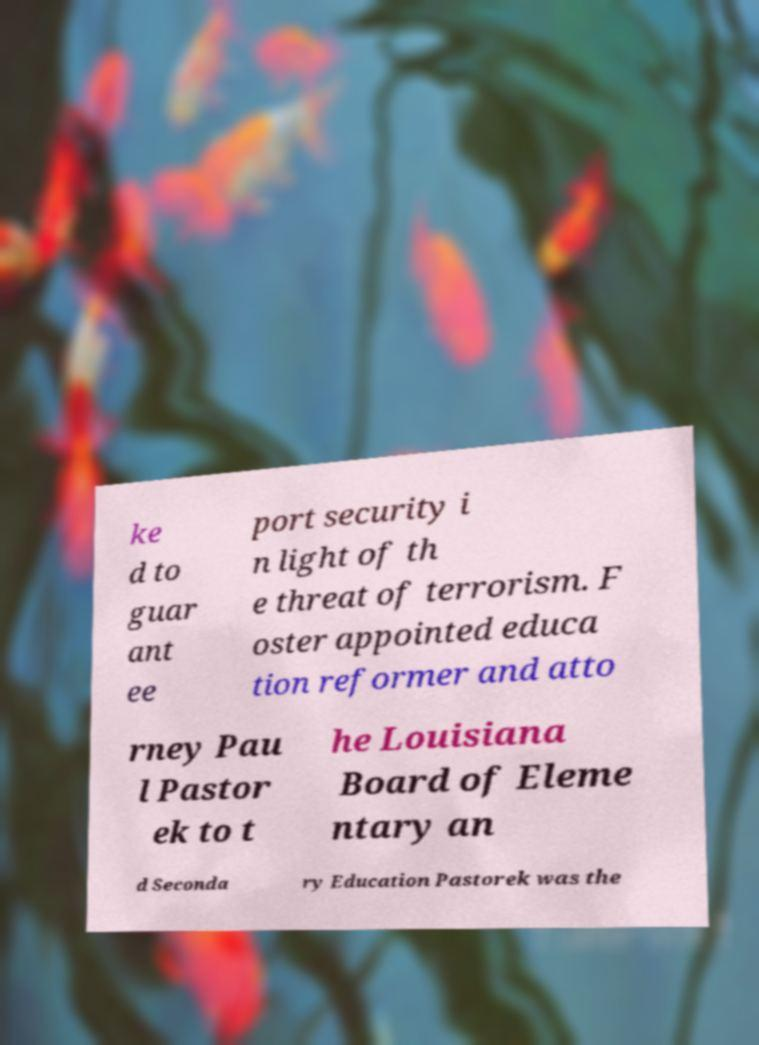For documentation purposes, I need the text within this image transcribed. Could you provide that? ke d to guar ant ee port security i n light of th e threat of terrorism. F oster appointed educa tion reformer and atto rney Pau l Pastor ek to t he Louisiana Board of Eleme ntary an d Seconda ry Education Pastorek was the 